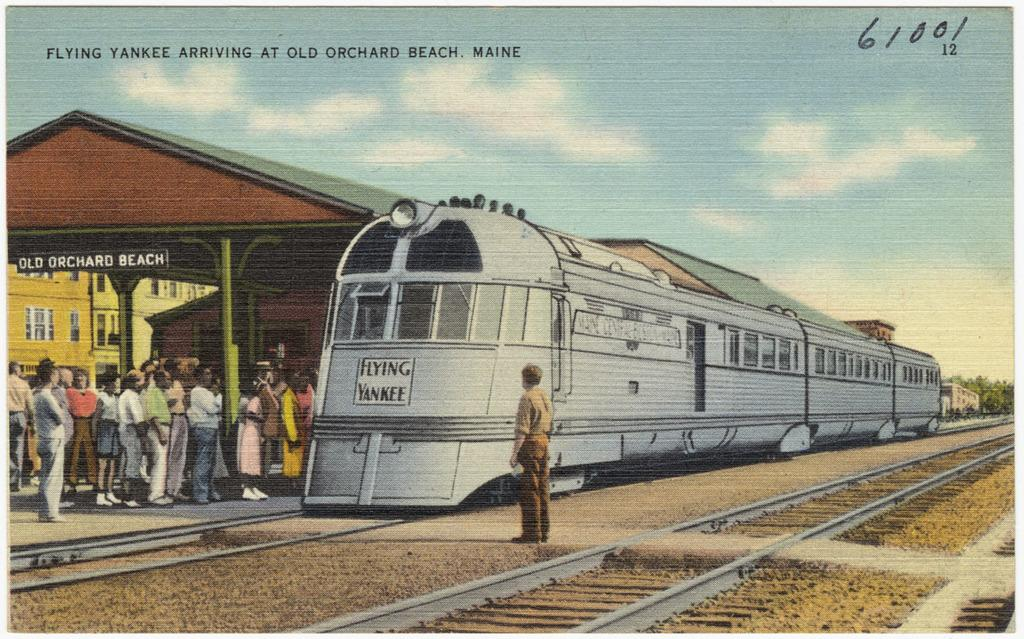<image>
Offer a succinct explanation of the picture presented. A train can be seen with a plaque on the front with the words Flying Yankee. 